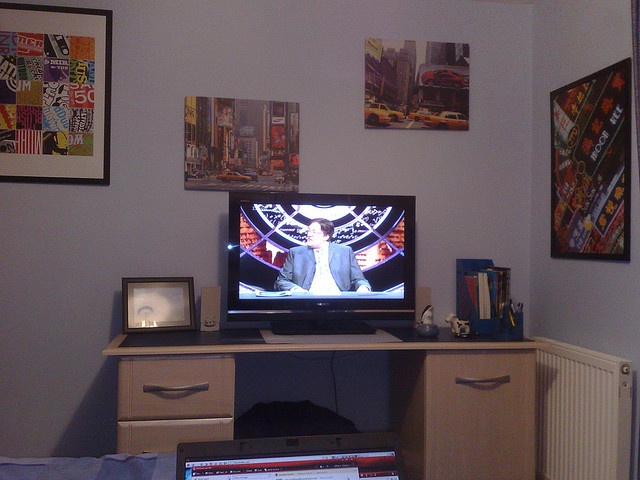Describe the objects in this image and their specific colors. I can see tv in gray, black, white, navy, and lightblue tones, laptop in gray, black, darkgray, and maroon tones, people in gray, lightblue, and white tones, car in gray, maroon, black, and brown tones, and book in gray and black tones in this image. 